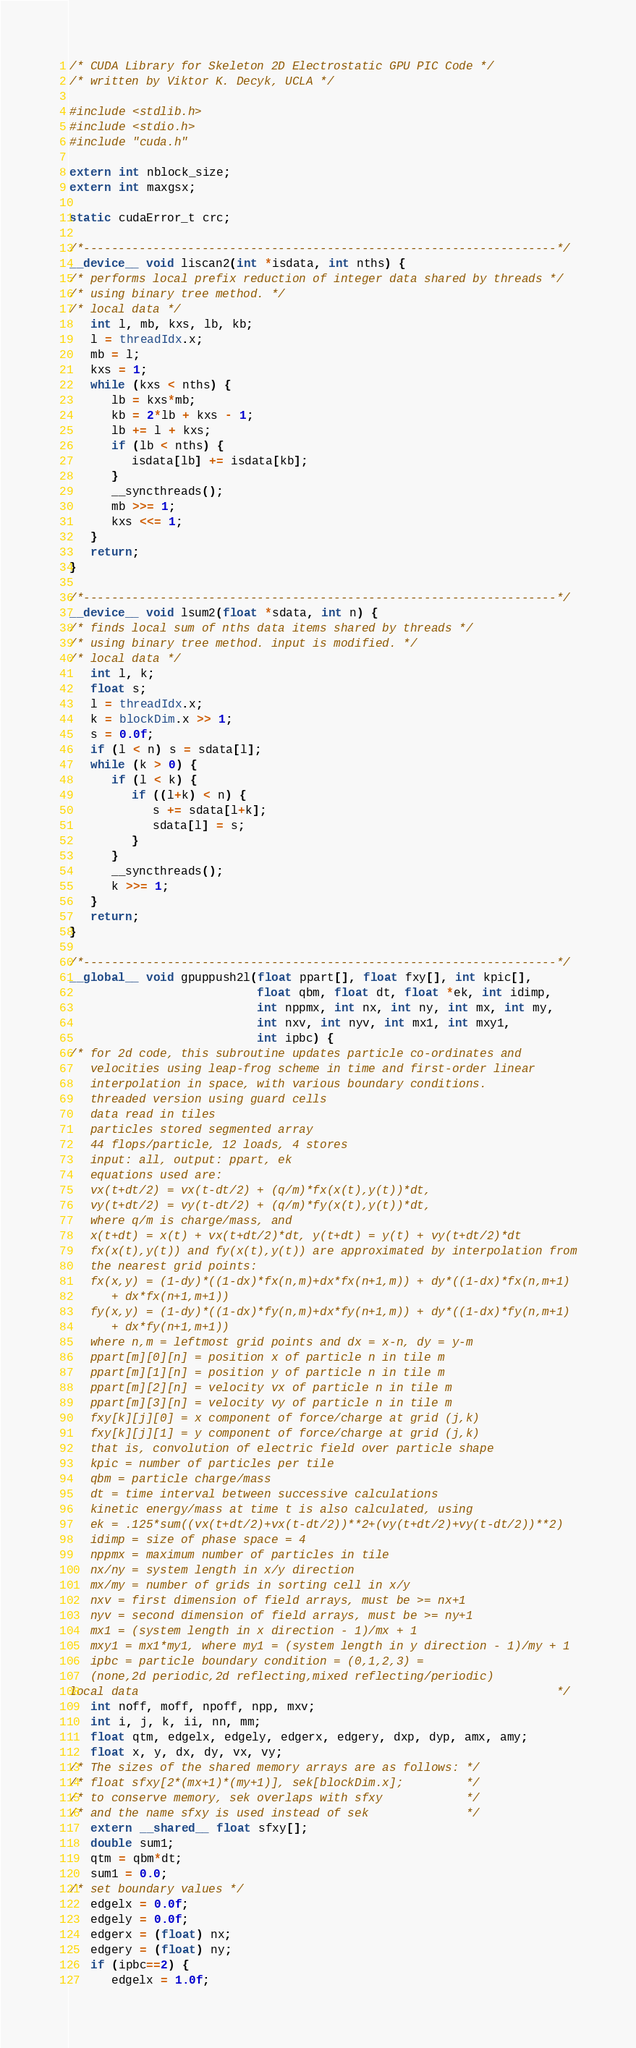<code> <loc_0><loc_0><loc_500><loc_500><_Cuda_>/* CUDA Library for Skeleton 2D Electrostatic GPU PIC Code */
/* written by Viktor K. Decyk, UCLA */

#include <stdlib.h>
#include <stdio.h>
#include "cuda.h"

extern int nblock_size;
extern int maxgsx;

static cudaError_t crc;

/*--------------------------------------------------------------------*/
__device__ void liscan2(int *isdata, int nths) {
/* performs local prefix reduction of integer data shared by threads */
/* using binary tree method. */
/* local data */
   int l, mb, kxs, lb, kb;
   l = threadIdx.x;
   mb = l;
   kxs = 1;
   while (kxs < nths) {
      lb = kxs*mb;
      kb = 2*lb + kxs - 1;
      lb += l + kxs;
      if (lb < nths) {
         isdata[lb] += isdata[kb];
      }
      __syncthreads();
      mb >>= 1;
      kxs <<= 1;
   }
   return;
}

/*--------------------------------------------------------------------*/
__device__ void lsum2(float *sdata, int n) {
/* finds local sum of nths data items shared by threads */
/* using binary tree method. input is modified. */
/* local data */
   int l, k;
   float s;
   l = threadIdx.x;
   k = blockDim.x >> 1;
   s = 0.0f;
   if (l < n) s = sdata[l];
   while (k > 0) {
      if (l < k) {
         if ((l+k) < n) {
            s += sdata[l+k];
            sdata[l] = s;
         }
      }
      __syncthreads();
      k >>= 1;
   }
   return;
}

/*--------------------------------------------------------------------*/
__global__ void gpuppush2l(float ppart[], float fxy[], int kpic[],
                           float qbm, float dt, float *ek, int idimp,
                           int nppmx, int nx, int ny, int mx, int my,
                           int nxv, int nyv, int mx1, int mxy1,
                           int ipbc) {
/* for 2d code, this subroutine updates particle co-ordinates and
   velocities using leap-frog scheme in time and first-order linear
   interpolation in space, with various boundary conditions.
   threaded version using guard cells
   data read in tiles
   particles stored segmented array
   44 flops/particle, 12 loads, 4 stores
   input: all, output: ppart, ek
   equations used are:
   vx(t+dt/2) = vx(t-dt/2) + (q/m)*fx(x(t),y(t))*dt,
   vy(t+dt/2) = vy(t-dt/2) + (q/m)*fy(x(t),y(t))*dt,
   where q/m is charge/mass, and
   x(t+dt) = x(t) + vx(t+dt/2)*dt, y(t+dt) = y(t) + vy(t+dt/2)*dt
   fx(x(t),y(t)) and fy(x(t),y(t)) are approximated by interpolation from
   the nearest grid points:
   fx(x,y) = (1-dy)*((1-dx)*fx(n,m)+dx*fx(n+1,m)) + dy*((1-dx)*fx(n,m+1)
      + dx*fx(n+1,m+1))
   fy(x,y) = (1-dy)*((1-dx)*fy(n,m)+dx*fy(n+1,m)) + dy*((1-dx)*fy(n,m+1)
      + dx*fy(n+1,m+1))
   where n,m = leftmost grid points and dx = x-n, dy = y-m
   ppart[m][0][n] = position x of particle n in tile m
   ppart[m][1][n] = position y of particle n in tile m
   ppart[m][2][n] = velocity vx of particle n in tile m
   ppart[m][3][n] = velocity vy of particle n in tile m
   fxy[k][j][0] = x component of force/charge at grid (j,k)
   fxy[k][j][1] = y component of force/charge at grid (j,k)
   that is, convolution of electric field over particle shape
   kpic = number of particles per tile
   qbm = particle charge/mass
   dt = time interval between successive calculations
   kinetic energy/mass at time t is also calculated, using
   ek = .125*sum((vx(t+dt/2)+vx(t-dt/2))**2+(vy(t+dt/2)+vy(t-dt/2))**2)
   idimp = size of phase space = 4
   nppmx = maximum number of particles in tile
   nx/ny = system length in x/y direction
   mx/my = number of grids in sorting cell in x/y
   nxv = first dimension of field arrays, must be >= nx+1
   nyv = second dimension of field arrays, must be >= ny+1
   mx1 = (system length in x direction - 1)/mx + 1
   mxy1 = mx1*my1, where my1 = (system length in y direction - 1)/my + 1
   ipbc = particle boundary condition = (0,1,2,3) =
   (none,2d periodic,2d reflecting,mixed reflecting/periodic)
local data                                                            */
   int noff, moff, npoff, npp, mxv;
   int i, j, k, ii, nn, mm;
   float qtm, edgelx, edgely, edgerx, edgery, dxp, dyp, amx, amy;
   float x, y, dx, dy, vx, vy;
/* The sizes of the shared memory arrays are as follows: */
/* float sfxy[2*(mx+1)*(my+1)], sek[blockDim.x];         */
/* to conserve memory, sek overlaps with sfxy            */
/* and the name sfxy is used instead of sek              */
   extern __shared__ float sfxy[];
   double sum1;
   qtm = qbm*dt;
   sum1 = 0.0;
/* set boundary values */
   edgelx = 0.0f;
   edgely = 0.0f;
   edgerx = (float) nx;
   edgery = (float) ny;
   if (ipbc==2) {
      edgelx = 1.0f;</code> 